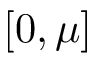Convert formula to latex. <formula><loc_0><loc_0><loc_500><loc_500>[ 0 , \mu ]</formula> 